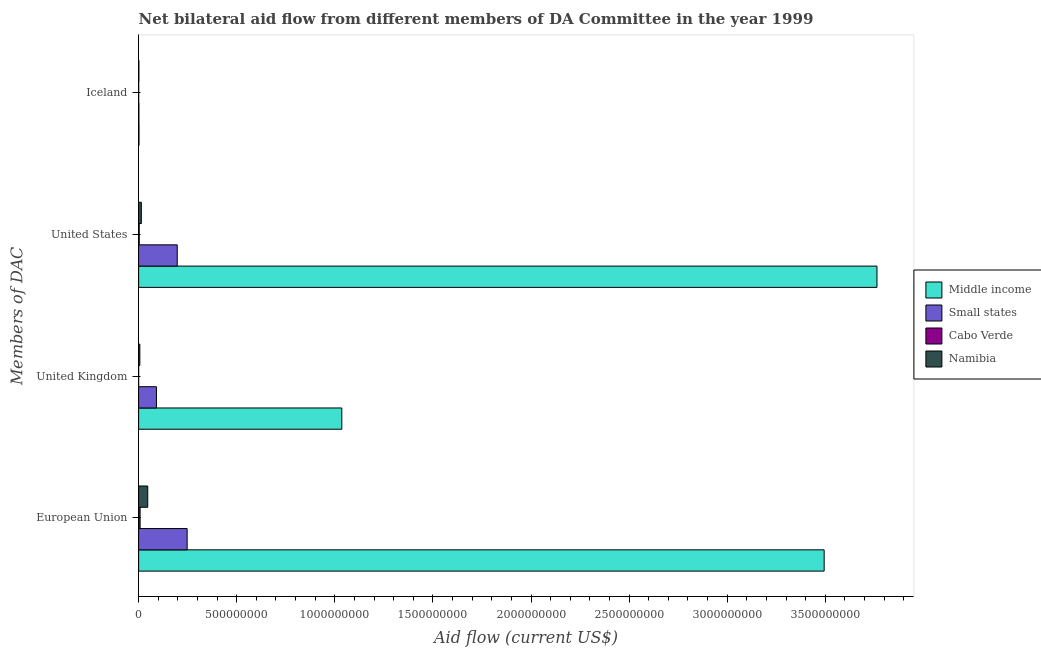How many different coloured bars are there?
Keep it short and to the point. 4. Are the number of bars on each tick of the Y-axis equal?
Ensure brevity in your answer.  Yes. How many bars are there on the 2nd tick from the bottom?
Keep it short and to the point. 4. What is the amount of aid given by uk in Namibia?
Your answer should be compact. 6.12e+06. Across all countries, what is the maximum amount of aid given by iceland?
Keep it short and to the point. 1.85e+06. Across all countries, what is the minimum amount of aid given by uk?
Make the answer very short. 2.00e+04. In which country was the amount of aid given by eu maximum?
Provide a succinct answer. Middle income. In which country was the amount of aid given by eu minimum?
Ensure brevity in your answer.  Cabo Verde. What is the total amount of aid given by uk in the graph?
Ensure brevity in your answer.  1.13e+09. What is the difference between the amount of aid given by eu in Middle income and that in Namibia?
Offer a very short reply. 3.45e+09. What is the difference between the amount of aid given by eu in Cabo Verde and the amount of aid given by uk in Namibia?
Keep it short and to the point. 1.35e+06. What is the average amount of aid given by eu per country?
Your answer should be very brief. 9.49e+08. What is the difference between the amount of aid given by eu and amount of aid given by us in Small states?
Provide a succinct answer. 5.05e+07. What is the ratio of the amount of aid given by eu in Namibia to that in Middle income?
Your answer should be compact. 0.01. Is the amount of aid given by eu in Cabo Verde less than that in Namibia?
Your response must be concise. Yes. What is the difference between the highest and the second highest amount of aid given by us?
Provide a succinct answer. 3.57e+09. What is the difference between the highest and the lowest amount of aid given by us?
Provide a short and direct response. 3.76e+09. Is the sum of the amount of aid given by uk in Namibia and Cabo Verde greater than the maximum amount of aid given by iceland across all countries?
Your answer should be very brief. Yes. What does the 1st bar from the top in United States represents?
Your response must be concise. Namibia. What does the 4th bar from the bottom in United Kingdom represents?
Provide a short and direct response. Namibia. Is it the case that in every country, the sum of the amount of aid given by eu and amount of aid given by uk is greater than the amount of aid given by us?
Provide a short and direct response. Yes. What is the difference between two consecutive major ticks on the X-axis?
Offer a very short reply. 5.00e+08. Are the values on the major ticks of X-axis written in scientific E-notation?
Give a very brief answer. No. Does the graph contain grids?
Offer a terse response. No. What is the title of the graph?
Offer a very short reply. Net bilateral aid flow from different members of DA Committee in the year 1999. Does "Montenegro" appear as one of the legend labels in the graph?
Your answer should be compact. No. What is the label or title of the X-axis?
Keep it short and to the point. Aid flow (current US$). What is the label or title of the Y-axis?
Your response must be concise. Members of DAC. What is the Aid flow (current US$) of Middle income in European Union?
Provide a succinct answer. 3.49e+09. What is the Aid flow (current US$) of Small states in European Union?
Provide a succinct answer. 2.47e+08. What is the Aid flow (current US$) of Cabo Verde in European Union?
Give a very brief answer. 7.47e+06. What is the Aid flow (current US$) of Namibia in European Union?
Ensure brevity in your answer.  4.65e+07. What is the Aid flow (current US$) of Middle income in United Kingdom?
Your answer should be very brief. 1.04e+09. What is the Aid flow (current US$) of Small states in United Kingdom?
Ensure brevity in your answer.  9.08e+07. What is the Aid flow (current US$) in Cabo Verde in United Kingdom?
Offer a terse response. 2.00e+04. What is the Aid flow (current US$) in Namibia in United Kingdom?
Provide a short and direct response. 6.12e+06. What is the Aid flow (current US$) in Middle income in United States?
Keep it short and to the point. 3.76e+09. What is the Aid flow (current US$) in Small states in United States?
Keep it short and to the point. 1.97e+08. What is the Aid flow (current US$) in Namibia in United States?
Offer a terse response. 1.39e+07. What is the Aid flow (current US$) of Middle income in Iceland?
Offer a very short reply. 1.85e+06. What is the Aid flow (current US$) in Small states in Iceland?
Offer a very short reply. 1.42e+06. What is the Aid flow (current US$) in Cabo Verde in Iceland?
Ensure brevity in your answer.  1.10e+05. What is the Aid flow (current US$) in Namibia in Iceland?
Your response must be concise. 1.31e+06. Across all Members of DAC, what is the maximum Aid flow (current US$) in Middle income?
Offer a very short reply. 3.76e+09. Across all Members of DAC, what is the maximum Aid flow (current US$) of Small states?
Offer a very short reply. 2.47e+08. Across all Members of DAC, what is the maximum Aid flow (current US$) of Cabo Verde?
Provide a succinct answer. 7.47e+06. Across all Members of DAC, what is the maximum Aid flow (current US$) of Namibia?
Provide a short and direct response. 4.65e+07. Across all Members of DAC, what is the minimum Aid flow (current US$) of Middle income?
Ensure brevity in your answer.  1.85e+06. Across all Members of DAC, what is the minimum Aid flow (current US$) of Small states?
Provide a succinct answer. 1.42e+06. Across all Members of DAC, what is the minimum Aid flow (current US$) of Namibia?
Ensure brevity in your answer.  1.31e+06. What is the total Aid flow (current US$) of Middle income in the graph?
Make the answer very short. 8.29e+09. What is the total Aid flow (current US$) in Small states in the graph?
Ensure brevity in your answer.  5.36e+08. What is the total Aid flow (current US$) in Cabo Verde in the graph?
Your answer should be compact. 1.06e+07. What is the total Aid flow (current US$) of Namibia in the graph?
Your answer should be very brief. 6.78e+07. What is the difference between the Aid flow (current US$) of Middle income in European Union and that in United Kingdom?
Ensure brevity in your answer.  2.46e+09. What is the difference between the Aid flow (current US$) of Small states in European Union and that in United Kingdom?
Ensure brevity in your answer.  1.56e+08. What is the difference between the Aid flow (current US$) in Cabo Verde in European Union and that in United Kingdom?
Keep it short and to the point. 7.45e+06. What is the difference between the Aid flow (current US$) of Namibia in European Union and that in United Kingdom?
Offer a terse response. 4.04e+07. What is the difference between the Aid flow (current US$) in Middle income in European Union and that in United States?
Your response must be concise. -2.69e+08. What is the difference between the Aid flow (current US$) of Small states in European Union and that in United States?
Your response must be concise. 5.05e+07. What is the difference between the Aid flow (current US$) in Cabo Verde in European Union and that in United States?
Give a very brief answer. 4.47e+06. What is the difference between the Aid flow (current US$) in Namibia in European Union and that in United States?
Your answer should be compact. 3.26e+07. What is the difference between the Aid flow (current US$) of Middle income in European Union and that in Iceland?
Your answer should be very brief. 3.49e+09. What is the difference between the Aid flow (current US$) in Small states in European Union and that in Iceland?
Your response must be concise. 2.46e+08. What is the difference between the Aid flow (current US$) of Cabo Verde in European Union and that in Iceland?
Offer a very short reply. 7.36e+06. What is the difference between the Aid flow (current US$) of Namibia in European Union and that in Iceland?
Your response must be concise. 4.52e+07. What is the difference between the Aid flow (current US$) in Middle income in United Kingdom and that in United States?
Make the answer very short. -2.73e+09. What is the difference between the Aid flow (current US$) of Small states in United Kingdom and that in United States?
Offer a very short reply. -1.06e+08. What is the difference between the Aid flow (current US$) in Cabo Verde in United Kingdom and that in United States?
Provide a succinct answer. -2.98e+06. What is the difference between the Aid flow (current US$) of Namibia in United Kingdom and that in United States?
Offer a terse response. -7.74e+06. What is the difference between the Aid flow (current US$) in Middle income in United Kingdom and that in Iceland?
Your answer should be compact. 1.03e+09. What is the difference between the Aid flow (current US$) in Small states in United Kingdom and that in Iceland?
Your answer should be very brief. 8.94e+07. What is the difference between the Aid flow (current US$) in Namibia in United Kingdom and that in Iceland?
Make the answer very short. 4.81e+06. What is the difference between the Aid flow (current US$) of Middle income in United States and that in Iceland?
Keep it short and to the point. 3.76e+09. What is the difference between the Aid flow (current US$) of Small states in United States and that in Iceland?
Ensure brevity in your answer.  1.95e+08. What is the difference between the Aid flow (current US$) in Cabo Verde in United States and that in Iceland?
Make the answer very short. 2.89e+06. What is the difference between the Aid flow (current US$) in Namibia in United States and that in Iceland?
Your answer should be compact. 1.26e+07. What is the difference between the Aid flow (current US$) of Middle income in European Union and the Aid flow (current US$) of Small states in United Kingdom?
Ensure brevity in your answer.  3.40e+09. What is the difference between the Aid flow (current US$) in Middle income in European Union and the Aid flow (current US$) in Cabo Verde in United Kingdom?
Your answer should be very brief. 3.49e+09. What is the difference between the Aid flow (current US$) in Middle income in European Union and the Aid flow (current US$) in Namibia in United Kingdom?
Offer a very short reply. 3.49e+09. What is the difference between the Aid flow (current US$) in Small states in European Union and the Aid flow (current US$) in Cabo Verde in United Kingdom?
Offer a terse response. 2.47e+08. What is the difference between the Aid flow (current US$) in Small states in European Union and the Aid flow (current US$) in Namibia in United Kingdom?
Keep it short and to the point. 2.41e+08. What is the difference between the Aid flow (current US$) of Cabo Verde in European Union and the Aid flow (current US$) of Namibia in United Kingdom?
Your response must be concise. 1.35e+06. What is the difference between the Aid flow (current US$) of Middle income in European Union and the Aid flow (current US$) of Small states in United States?
Your response must be concise. 3.30e+09. What is the difference between the Aid flow (current US$) of Middle income in European Union and the Aid flow (current US$) of Cabo Verde in United States?
Your answer should be very brief. 3.49e+09. What is the difference between the Aid flow (current US$) of Middle income in European Union and the Aid flow (current US$) of Namibia in United States?
Keep it short and to the point. 3.48e+09. What is the difference between the Aid flow (current US$) of Small states in European Union and the Aid flow (current US$) of Cabo Verde in United States?
Provide a succinct answer. 2.44e+08. What is the difference between the Aid flow (current US$) in Small states in European Union and the Aid flow (current US$) in Namibia in United States?
Offer a terse response. 2.33e+08. What is the difference between the Aid flow (current US$) of Cabo Verde in European Union and the Aid flow (current US$) of Namibia in United States?
Offer a terse response. -6.39e+06. What is the difference between the Aid flow (current US$) in Middle income in European Union and the Aid flow (current US$) in Small states in Iceland?
Offer a very short reply. 3.49e+09. What is the difference between the Aid flow (current US$) in Middle income in European Union and the Aid flow (current US$) in Cabo Verde in Iceland?
Make the answer very short. 3.49e+09. What is the difference between the Aid flow (current US$) of Middle income in European Union and the Aid flow (current US$) of Namibia in Iceland?
Make the answer very short. 3.49e+09. What is the difference between the Aid flow (current US$) of Small states in European Union and the Aid flow (current US$) of Cabo Verde in Iceland?
Keep it short and to the point. 2.47e+08. What is the difference between the Aid flow (current US$) of Small states in European Union and the Aid flow (current US$) of Namibia in Iceland?
Make the answer very short. 2.46e+08. What is the difference between the Aid flow (current US$) in Cabo Verde in European Union and the Aid flow (current US$) in Namibia in Iceland?
Your response must be concise. 6.16e+06. What is the difference between the Aid flow (current US$) of Middle income in United Kingdom and the Aid flow (current US$) of Small states in United States?
Your response must be concise. 8.39e+08. What is the difference between the Aid flow (current US$) of Middle income in United Kingdom and the Aid flow (current US$) of Cabo Verde in United States?
Provide a succinct answer. 1.03e+09. What is the difference between the Aid flow (current US$) in Middle income in United Kingdom and the Aid flow (current US$) in Namibia in United States?
Provide a succinct answer. 1.02e+09. What is the difference between the Aid flow (current US$) of Small states in United Kingdom and the Aid flow (current US$) of Cabo Verde in United States?
Ensure brevity in your answer.  8.78e+07. What is the difference between the Aid flow (current US$) of Small states in United Kingdom and the Aid flow (current US$) of Namibia in United States?
Give a very brief answer. 7.69e+07. What is the difference between the Aid flow (current US$) in Cabo Verde in United Kingdom and the Aid flow (current US$) in Namibia in United States?
Provide a succinct answer. -1.38e+07. What is the difference between the Aid flow (current US$) of Middle income in United Kingdom and the Aid flow (current US$) of Small states in Iceland?
Ensure brevity in your answer.  1.03e+09. What is the difference between the Aid flow (current US$) in Middle income in United Kingdom and the Aid flow (current US$) in Cabo Verde in Iceland?
Provide a short and direct response. 1.04e+09. What is the difference between the Aid flow (current US$) of Middle income in United Kingdom and the Aid flow (current US$) of Namibia in Iceland?
Ensure brevity in your answer.  1.03e+09. What is the difference between the Aid flow (current US$) in Small states in United Kingdom and the Aid flow (current US$) in Cabo Verde in Iceland?
Offer a very short reply. 9.07e+07. What is the difference between the Aid flow (current US$) of Small states in United Kingdom and the Aid flow (current US$) of Namibia in Iceland?
Give a very brief answer. 8.95e+07. What is the difference between the Aid flow (current US$) of Cabo Verde in United Kingdom and the Aid flow (current US$) of Namibia in Iceland?
Provide a succinct answer. -1.29e+06. What is the difference between the Aid flow (current US$) in Middle income in United States and the Aid flow (current US$) in Small states in Iceland?
Keep it short and to the point. 3.76e+09. What is the difference between the Aid flow (current US$) of Middle income in United States and the Aid flow (current US$) of Cabo Verde in Iceland?
Keep it short and to the point. 3.76e+09. What is the difference between the Aid flow (current US$) of Middle income in United States and the Aid flow (current US$) of Namibia in Iceland?
Give a very brief answer. 3.76e+09. What is the difference between the Aid flow (current US$) in Small states in United States and the Aid flow (current US$) in Cabo Verde in Iceland?
Your answer should be very brief. 1.97e+08. What is the difference between the Aid flow (current US$) of Small states in United States and the Aid flow (current US$) of Namibia in Iceland?
Your answer should be very brief. 1.95e+08. What is the difference between the Aid flow (current US$) in Cabo Verde in United States and the Aid flow (current US$) in Namibia in Iceland?
Your response must be concise. 1.69e+06. What is the average Aid flow (current US$) of Middle income per Members of DAC?
Give a very brief answer. 2.07e+09. What is the average Aid flow (current US$) in Small states per Members of DAC?
Offer a very short reply. 1.34e+08. What is the average Aid flow (current US$) in Cabo Verde per Members of DAC?
Provide a short and direct response. 2.65e+06. What is the average Aid flow (current US$) in Namibia per Members of DAC?
Your response must be concise. 1.69e+07. What is the difference between the Aid flow (current US$) in Middle income and Aid flow (current US$) in Small states in European Union?
Make the answer very short. 3.25e+09. What is the difference between the Aid flow (current US$) of Middle income and Aid flow (current US$) of Cabo Verde in European Union?
Give a very brief answer. 3.49e+09. What is the difference between the Aid flow (current US$) of Middle income and Aid flow (current US$) of Namibia in European Union?
Your answer should be very brief. 3.45e+09. What is the difference between the Aid flow (current US$) of Small states and Aid flow (current US$) of Cabo Verde in European Union?
Ensure brevity in your answer.  2.40e+08. What is the difference between the Aid flow (current US$) of Small states and Aid flow (current US$) of Namibia in European Union?
Ensure brevity in your answer.  2.01e+08. What is the difference between the Aid flow (current US$) of Cabo Verde and Aid flow (current US$) of Namibia in European Union?
Keep it short and to the point. -3.90e+07. What is the difference between the Aid flow (current US$) of Middle income and Aid flow (current US$) of Small states in United Kingdom?
Make the answer very short. 9.45e+08. What is the difference between the Aid flow (current US$) in Middle income and Aid flow (current US$) in Cabo Verde in United Kingdom?
Offer a terse response. 1.04e+09. What is the difference between the Aid flow (current US$) in Middle income and Aid flow (current US$) in Namibia in United Kingdom?
Your answer should be very brief. 1.03e+09. What is the difference between the Aid flow (current US$) of Small states and Aid flow (current US$) of Cabo Verde in United Kingdom?
Your answer should be compact. 9.08e+07. What is the difference between the Aid flow (current US$) in Small states and Aid flow (current US$) in Namibia in United Kingdom?
Your answer should be compact. 8.46e+07. What is the difference between the Aid flow (current US$) in Cabo Verde and Aid flow (current US$) in Namibia in United Kingdom?
Offer a very short reply. -6.10e+06. What is the difference between the Aid flow (current US$) of Middle income and Aid flow (current US$) of Small states in United States?
Your answer should be very brief. 3.57e+09. What is the difference between the Aid flow (current US$) of Middle income and Aid flow (current US$) of Cabo Verde in United States?
Make the answer very short. 3.76e+09. What is the difference between the Aid flow (current US$) in Middle income and Aid flow (current US$) in Namibia in United States?
Ensure brevity in your answer.  3.75e+09. What is the difference between the Aid flow (current US$) of Small states and Aid flow (current US$) of Cabo Verde in United States?
Ensure brevity in your answer.  1.94e+08. What is the difference between the Aid flow (current US$) in Small states and Aid flow (current US$) in Namibia in United States?
Your answer should be very brief. 1.83e+08. What is the difference between the Aid flow (current US$) in Cabo Verde and Aid flow (current US$) in Namibia in United States?
Your response must be concise. -1.09e+07. What is the difference between the Aid flow (current US$) in Middle income and Aid flow (current US$) in Cabo Verde in Iceland?
Ensure brevity in your answer.  1.74e+06. What is the difference between the Aid flow (current US$) in Middle income and Aid flow (current US$) in Namibia in Iceland?
Give a very brief answer. 5.40e+05. What is the difference between the Aid flow (current US$) of Small states and Aid flow (current US$) of Cabo Verde in Iceland?
Your response must be concise. 1.31e+06. What is the difference between the Aid flow (current US$) of Cabo Verde and Aid flow (current US$) of Namibia in Iceland?
Keep it short and to the point. -1.20e+06. What is the ratio of the Aid flow (current US$) of Middle income in European Union to that in United Kingdom?
Your response must be concise. 3.37. What is the ratio of the Aid flow (current US$) of Small states in European Union to that in United Kingdom?
Offer a very short reply. 2.72. What is the ratio of the Aid flow (current US$) in Cabo Verde in European Union to that in United Kingdom?
Give a very brief answer. 373.5. What is the ratio of the Aid flow (current US$) of Namibia in European Union to that in United Kingdom?
Provide a short and direct response. 7.6. What is the ratio of the Aid flow (current US$) in Middle income in European Union to that in United States?
Your response must be concise. 0.93. What is the ratio of the Aid flow (current US$) in Small states in European Union to that in United States?
Your answer should be very brief. 1.26. What is the ratio of the Aid flow (current US$) of Cabo Verde in European Union to that in United States?
Provide a short and direct response. 2.49. What is the ratio of the Aid flow (current US$) in Namibia in European Union to that in United States?
Keep it short and to the point. 3.35. What is the ratio of the Aid flow (current US$) of Middle income in European Union to that in Iceland?
Provide a short and direct response. 1888.69. What is the ratio of the Aid flow (current US$) of Small states in European Union to that in Iceland?
Your response must be concise. 174.11. What is the ratio of the Aid flow (current US$) of Cabo Verde in European Union to that in Iceland?
Give a very brief answer. 67.91. What is the ratio of the Aid flow (current US$) of Namibia in European Union to that in Iceland?
Ensure brevity in your answer.  35.49. What is the ratio of the Aid flow (current US$) of Middle income in United Kingdom to that in United States?
Ensure brevity in your answer.  0.28. What is the ratio of the Aid flow (current US$) of Small states in United Kingdom to that in United States?
Your answer should be very brief. 0.46. What is the ratio of the Aid flow (current US$) of Cabo Verde in United Kingdom to that in United States?
Keep it short and to the point. 0.01. What is the ratio of the Aid flow (current US$) of Namibia in United Kingdom to that in United States?
Provide a succinct answer. 0.44. What is the ratio of the Aid flow (current US$) of Middle income in United Kingdom to that in Iceland?
Offer a very short reply. 559.77. What is the ratio of the Aid flow (current US$) of Small states in United Kingdom to that in Iceland?
Make the answer very short. 63.92. What is the ratio of the Aid flow (current US$) of Cabo Verde in United Kingdom to that in Iceland?
Give a very brief answer. 0.18. What is the ratio of the Aid flow (current US$) in Namibia in United Kingdom to that in Iceland?
Provide a succinct answer. 4.67. What is the ratio of the Aid flow (current US$) of Middle income in United States to that in Iceland?
Provide a short and direct response. 2034.17. What is the ratio of the Aid flow (current US$) of Small states in United States to that in Iceland?
Your answer should be compact. 138.56. What is the ratio of the Aid flow (current US$) in Cabo Verde in United States to that in Iceland?
Ensure brevity in your answer.  27.27. What is the ratio of the Aid flow (current US$) of Namibia in United States to that in Iceland?
Keep it short and to the point. 10.58. What is the difference between the highest and the second highest Aid flow (current US$) in Middle income?
Your response must be concise. 2.69e+08. What is the difference between the highest and the second highest Aid flow (current US$) of Small states?
Provide a succinct answer. 5.05e+07. What is the difference between the highest and the second highest Aid flow (current US$) in Cabo Verde?
Make the answer very short. 4.47e+06. What is the difference between the highest and the second highest Aid flow (current US$) of Namibia?
Make the answer very short. 3.26e+07. What is the difference between the highest and the lowest Aid flow (current US$) in Middle income?
Provide a succinct answer. 3.76e+09. What is the difference between the highest and the lowest Aid flow (current US$) of Small states?
Your answer should be very brief. 2.46e+08. What is the difference between the highest and the lowest Aid flow (current US$) of Cabo Verde?
Give a very brief answer. 7.45e+06. What is the difference between the highest and the lowest Aid flow (current US$) in Namibia?
Make the answer very short. 4.52e+07. 